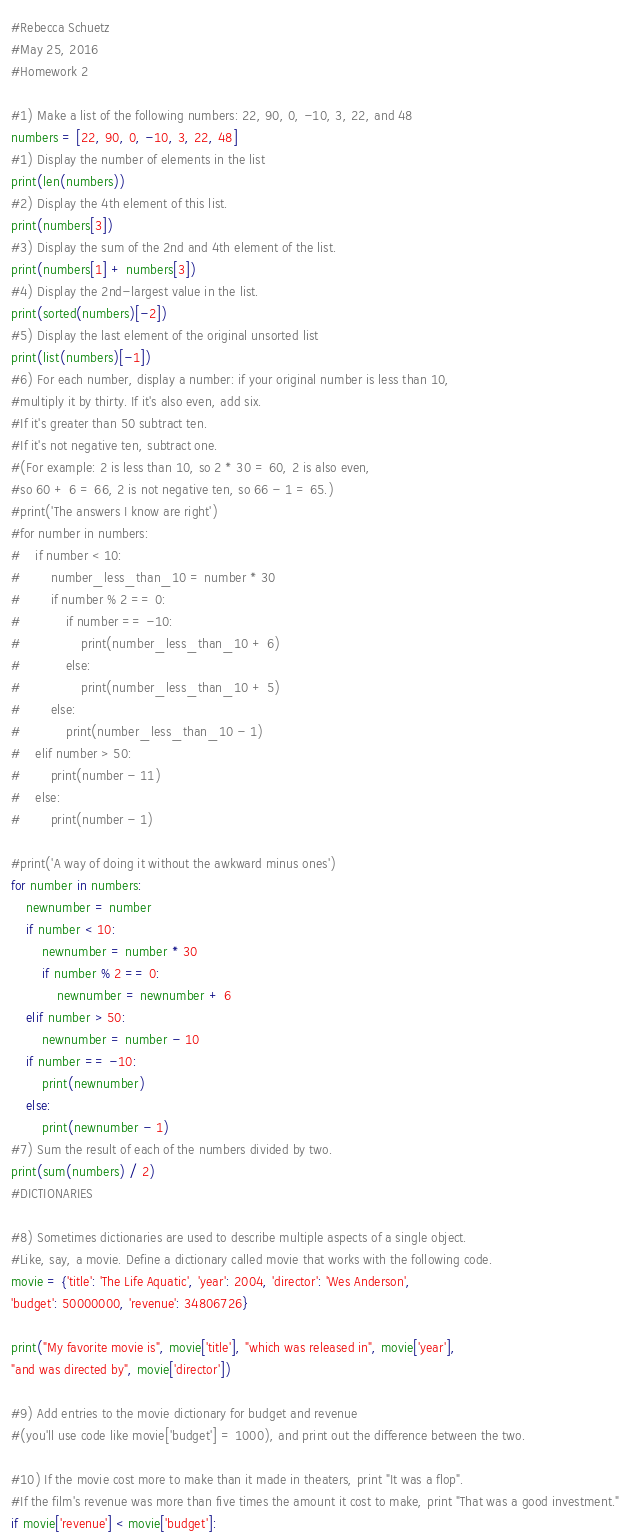<code> <loc_0><loc_0><loc_500><loc_500><_Python_>#Rebecca Schuetz
#May 25, 2016
#Homework 2

#1) Make a list of the following numbers: 22, 90, 0, -10, 3, 22, and 48
numbers = [22, 90, 0, -10, 3, 22, 48]
#1) Display the number of elements in the list
print(len(numbers))
#2) Display the 4th element of this list.
print(numbers[3])
#3) Display the sum of the 2nd and 4th element of the list.
print(numbers[1] + numbers[3])
#4) Display the 2nd-largest value in the list.
print(sorted(numbers)[-2])
#5) Display the last element of the original unsorted list
print(list(numbers)[-1])
#6) For each number, display a number: if your original number is less than 10,
#multiply it by thirty. If it's also even, add six.
#If it's greater than 50 subtract ten.
#If it's not negative ten, subtract one.
#(For example: 2 is less than 10, so 2 * 30 = 60, 2 is also even,
#so 60 + 6 = 66, 2 is not negative ten, so 66 - 1 = 65.)
#print('The answers I know are right')
#for number in numbers:
#    if number < 10:
#        number_less_than_10 = number * 30
#        if number % 2 == 0:
#            if number == -10:
#                print(number_less_than_10 + 6)
#            else:
#                print(number_less_than_10 + 5)
#        else:
#            print(number_less_than_10 - 1)
#    elif number > 50:
#        print(number - 11)
#    else:
#        print(number - 1)

#print('A way of doing it without the awkward minus ones')
for number in numbers:
    newnumber = number
    if number < 10:
        newnumber = number * 30
        if number % 2 == 0:
            newnumber = newnumber + 6
    elif number > 50:
        newnumber = number - 10
    if number == -10:
        print(newnumber)
    else:
        print(newnumber - 1)
#7) Sum the result of each of the numbers divided by two.
print(sum(numbers) / 2)
#DICTIONARIES

#8) Sometimes dictionaries are used to describe multiple aspects of a single object.
#Like, say, a movie. Define a dictionary called movie that works with the following code.
movie = {'title': 'The Life Aquatic', 'year': 2004, 'director': 'Wes Anderson',
'budget': 50000000, 'revenue': 34806726}

print("My favorite movie is", movie['title'], "which was released in", movie['year'],
"and was directed by", movie['director'])

#9) Add entries to the movie dictionary for budget and revenue
#(you'll use code like movie['budget'] = 1000), and print out the difference between the two.

#10) If the movie cost more to make than it made in theaters, print "It was a flop".
#If the film's revenue was more than five times the amount it cost to make, print "That was a good investment."
if movie['revenue'] < movie['budget']:</code> 